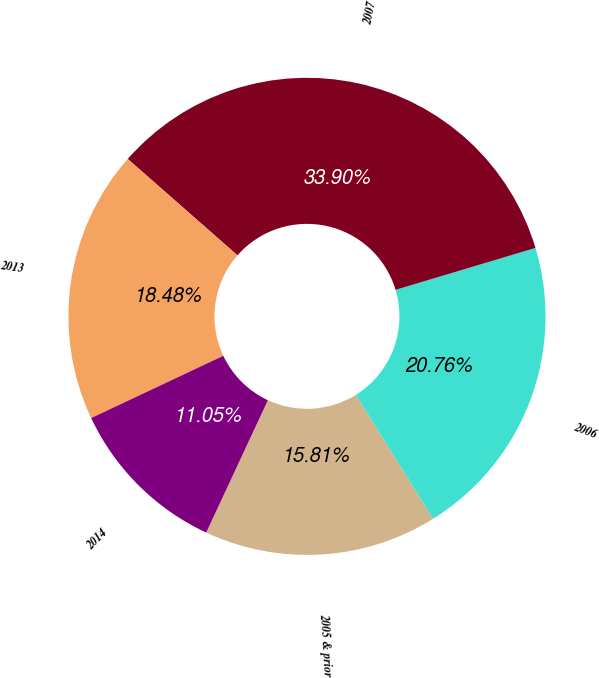Convert chart to OTSL. <chart><loc_0><loc_0><loc_500><loc_500><pie_chart><fcel>2005 & prior<fcel>2006<fcel>2007<fcel>2013<fcel>2014<nl><fcel>15.81%<fcel>20.76%<fcel>33.9%<fcel>18.48%<fcel>11.05%<nl></chart> 